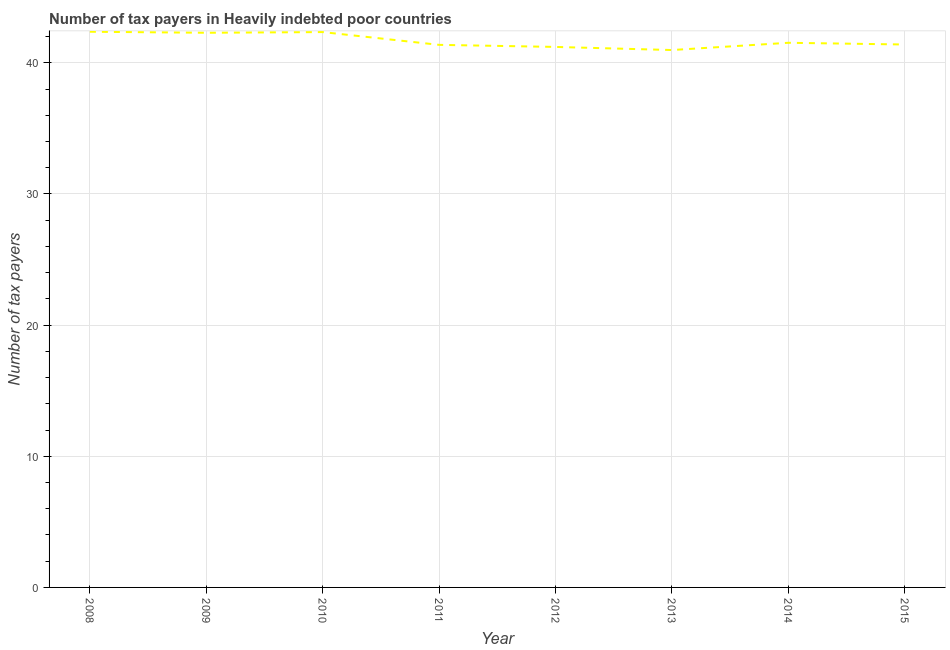What is the number of tax payers in 2010?
Provide a short and direct response. 42.34. Across all years, what is the maximum number of tax payers?
Make the answer very short. 42.37. Across all years, what is the minimum number of tax payers?
Your response must be concise. 40.97. What is the sum of the number of tax payers?
Make the answer very short. 333.47. What is the difference between the number of tax payers in 2011 and 2013?
Keep it short and to the point. 0.39. What is the average number of tax payers per year?
Keep it short and to the point. 41.68. What is the median number of tax payers?
Your answer should be compact. 41.46. What is the ratio of the number of tax payers in 2008 to that in 2014?
Offer a terse response. 1.02. Is the number of tax payers in 2008 less than that in 2013?
Your response must be concise. No. Is the difference between the number of tax payers in 2009 and 2011 greater than the difference between any two years?
Keep it short and to the point. No. What is the difference between the highest and the second highest number of tax payers?
Offer a terse response. 0.03. What is the difference between the highest and the lowest number of tax payers?
Make the answer very short. 1.39. In how many years, is the number of tax payers greater than the average number of tax payers taken over all years?
Your answer should be very brief. 3. Are the values on the major ticks of Y-axis written in scientific E-notation?
Make the answer very short. No. Does the graph contain any zero values?
Make the answer very short. No. What is the title of the graph?
Offer a very short reply. Number of tax payers in Heavily indebted poor countries. What is the label or title of the Y-axis?
Make the answer very short. Number of tax payers. What is the Number of tax payers in 2008?
Your answer should be very brief. 42.37. What is the Number of tax payers in 2009?
Offer a very short reply. 42.29. What is the Number of tax payers in 2010?
Your answer should be very brief. 42.34. What is the Number of tax payers of 2011?
Keep it short and to the point. 41.37. What is the Number of tax payers in 2012?
Make the answer very short. 41.21. What is the Number of tax payers of 2013?
Keep it short and to the point. 40.97. What is the Number of tax payers in 2014?
Give a very brief answer. 41.53. What is the Number of tax payers of 2015?
Offer a terse response. 41.39. What is the difference between the Number of tax payers in 2008 and 2009?
Your response must be concise. 0.08. What is the difference between the Number of tax payers in 2008 and 2010?
Your answer should be compact. 0.03. What is the difference between the Number of tax payers in 2008 and 2011?
Offer a very short reply. 1. What is the difference between the Number of tax payers in 2008 and 2012?
Your answer should be very brief. 1.16. What is the difference between the Number of tax payers in 2008 and 2013?
Keep it short and to the point. 1.39. What is the difference between the Number of tax payers in 2008 and 2014?
Ensure brevity in your answer.  0.84. What is the difference between the Number of tax payers in 2008 and 2015?
Provide a succinct answer. 0.97. What is the difference between the Number of tax payers in 2009 and 2010?
Provide a short and direct response. -0.05. What is the difference between the Number of tax payers in 2009 and 2011?
Offer a terse response. 0.92. What is the difference between the Number of tax payers in 2009 and 2012?
Make the answer very short. 1.08. What is the difference between the Number of tax payers in 2009 and 2013?
Your answer should be very brief. 1.32. What is the difference between the Number of tax payers in 2009 and 2014?
Offer a terse response. 0.76. What is the difference between the Number of tax payers in 2009 and 2015?
Provide a succinct answer. 0.89. What is the difference between the Number of tax payers in 2010 and 2011?
Make the answer very short. 0.97. What is the difference between the Number of tax payers in 2010 and 2012?
Your answer should be very brief. 1.13. What is the difference between the Number of tax payers in 2010 and 2013?
Offer a terse response. 1.37. What is the difference between the Number of tax payers in 2010 and 2014?
Provide a succinct answer. 0.82. What is the difference between the Number of tax payers in 2010 and 2015?
Offer a terse response. 0.95. What is the difference between the Number of tax payers in 2011 and 2012?
Offer a very short reply. 0.16. What is the difference between the Number of tax payers in 2011 and 2013?
Your answer should be very brief. 0.39. What is the difference between the Number of tax payers in 2011 and 2014?
Keep it short and to the point. -0.16. What is the difference between the Number of tax payers in 2011 and 2015?
Keep it short and to the point. -0.03. What is the difference between the Number of tax payers in 2012 and 2013?
Provide a short and direct response. 0.24. What is the difference between the Number of tax payers in 2012 and 2014?
Offer a very short reply. -0.32. What is the difference between the Number of tax payers in 2012 and 2015?
Make the answer very short. -0.18. What is the difference between the Number of tax payers in 2013 and 2014?
Your response must be concise. -0.55. What is the difference between the Number of tax payers in 2013 and 2015?
Make the answer very short. -0.42. What is the difference between the Number of tax payers in 2014 and 2015?
Offer a very short reply. 0.13. What is the ratio of the Number of tax payers in 2008 to that in 2012?
Make the answer very short. 1.03. What is the ratio of the Number of tax payers in 2008 to that in 2013?
Your response must be concise. 1.03. What is the ratio of the Number of tax payers in 2008 to that in 2014?
Make the answer very short. 1.02. What is the ratio of the Number of tax payers in 2008 to that in 2015?
Your answer should be compact. 1.02. What is the ratio of the Number of tax payers in 2009 to that in 2013?
Offer a terse response. 1.03. What is the ratio of the Number of tax payers in 2009 to that in 2015?
Make the answer very short. 1.02. What is the ratio of the Number of tax payers in 2010 to that in 2011?
Offer a very short reply. 1.02. What is the ratio of the Number of tax payers in 2010 to that in 2012?
Give a very brief answer. 1.03. What is the ratio of the Number of tax payers in 2010 to that in 2013?
Provide a succinct answer. 1.03. What is the ratio of the Number of tax payers in 2011 to that in 2012?
Keep it short and to the point. 1. What is the ratio of the Number of tax payers in 2011 to that in 2014?
Offer a terse response. 1. What is the ratio of the Number of tax payers in 2012 to that in 2013?
Your answer should be compact. 1.01. What is the ratio of the Number of tax payers in 2012 to that in 2014?
Your answer should be compact. 0.99. What is the ratio of the Number of tax payers in 2013 to that in 2015?
Keep it short and to the point. 0.99. What is the ratio of the Number of tax payers in 2014 to that in 2015?
Keep it short and to the point. 1. 